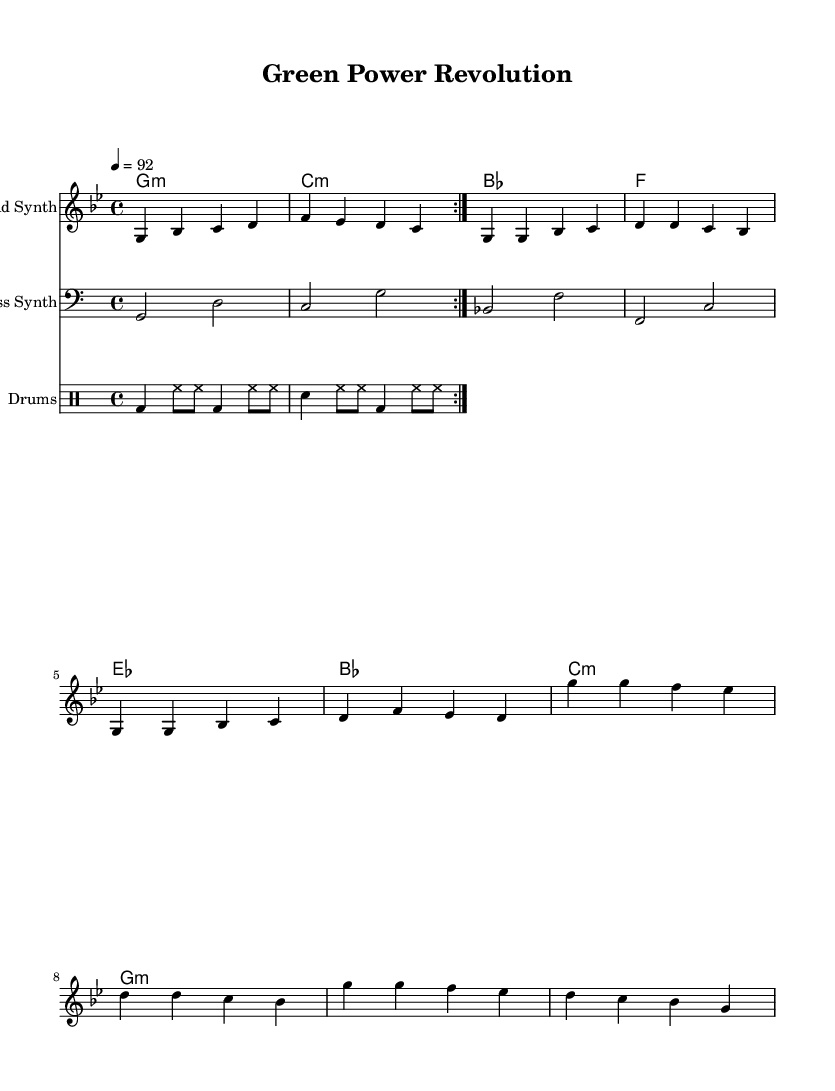What is the key signature of this music? The key signature is G minor, which has two flats (B flat and E flat).
Answer: G minor What is the time signature of this music? The time signature displayed at the beginning of the sheet music is 4/4, meaning there are four beats per measure.
Answer: 4/4 What is the tempo marking for this piece? The tempo marking indicates the speed of the music, which is set to quarter note equals 92 beats per minute.
Answer: 92 What chord does the bass line start with? The bass line begins with the note G, indicating that the first chord is built on G.
Answer: G How many measures are in the chorus section of the song? By observing the drum patterns and counting the repetitions, we can see that the chorus section consists of four measures total, repeated during the performance.
Answer: 4 What type of instrument is the melody played on? The melody is designated for "Lead Synth," indicating that it is played on a synthesizer, which is common in Hip Hop music.
Answer: Lead Synth What rhythmic element is characteristic of the Hip Hop style in this piece? The drum patterns include kick drums and snare drumming often found in Hip Hop, indicating a consistent beat and groove typical of the genre.
Answer: Kick and snare 